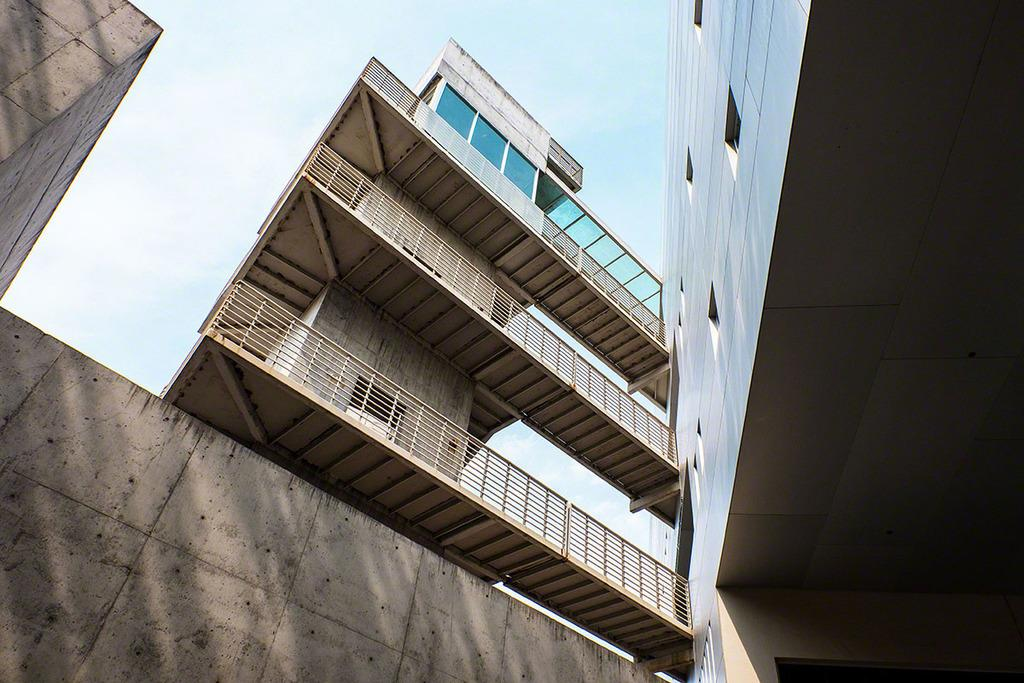What type of structures can be seen in the image? There are buildings in the image. What else is present in the image besides the buildings? There is a wall in the image. How would you describe the sky in the image? The sky is blue and cloudy in the image. Can you tell me how many goats are standing on the wall in the image? There are no goats present in the image; it only features buildings, a wall, and a blue and cloudy sky. 